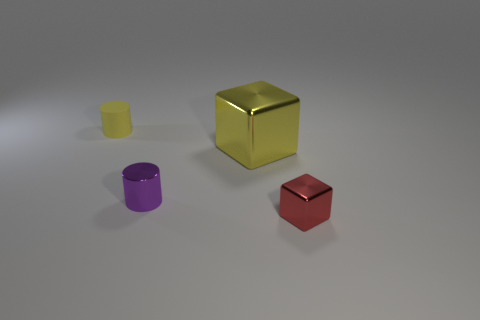How many other objects are the same shape as the tiny purple thing?
Your answer should be very brief. 1. Is the red thing made of the same material as the small purple cylinder?
Offer a very short reply. Yes. What is the material of the object that is both behind the tiny purple cylinder and left of the large yellow thing?
Keep it short and to the point. Rubber. There is a tiny matte object left of the small purple thing; what is its color?
Offer a terse response. Yellow. Is the number of big things that are on the right side of the red object greater than the number of large brown spheres?
Keep it short and to the point. No. What number of other things are the same size as the metallic cylinder?
Your response must be concise. 2. There is a tiny purple cylinder; how many large yellow things are to the left of it?
Your response must be concise. 0. Is the number of purple cylinders that are behind the yellow cylinder the same as the number of small yellow matte cylinders that are on the right side of the yellow block?
Your response must be concise. Yes. What is the size of the other object that is the same shape as the small purple object?
Make the answer very short. Small. The yellow thing that is right of the yellow rubber cylinder has what shape?
Provide a short and direct response. Cube. 